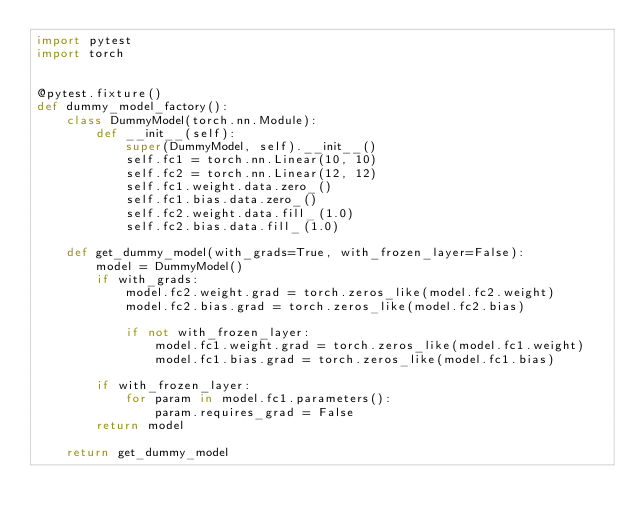<code> <loc_0><loc_0><loc_500><loc_500><_Python_>import pytest
import torch


@pytest.fixture()
def dummy_model_factory():
    class DummyModel(torch.nn.Module):
        def __init__(self):
            super(DummyModel, self).__init__()
            self.fc1 = torch.nn.Linear(10, 10)
            self.fc2 = torch.nn.Linear(12, 12)
            self.fc1.weight.data.zero_()
            self.fc1.bias.data.zero_()
            self.fc2.weight.data.fill_(1.0)
            self.fc2.bias.data.fill_(1.0)

    def get_dummy_model(with_grads=True, with_frozen_layer=False):
        model = DummyModel()
        if with_grads:
            model.fc2.weight.grad = torch.zeros_like(model.fc2.weight)
            model.fc2.bias.grad = torch.zeros_like(model.fc2.bias)

            if not with_frozen_layer:
                model.fc1.weight.grad = torch.zeros_like(model.fc1.weight)
                model.fc1.bias.grad = torch.zeros_like(model.fc1.bias)

        if with_frozen_layer:
            for param in model.fc1.parameters():
                param.requires_grad = False
        return model

    return get_dummy_model
</code> 